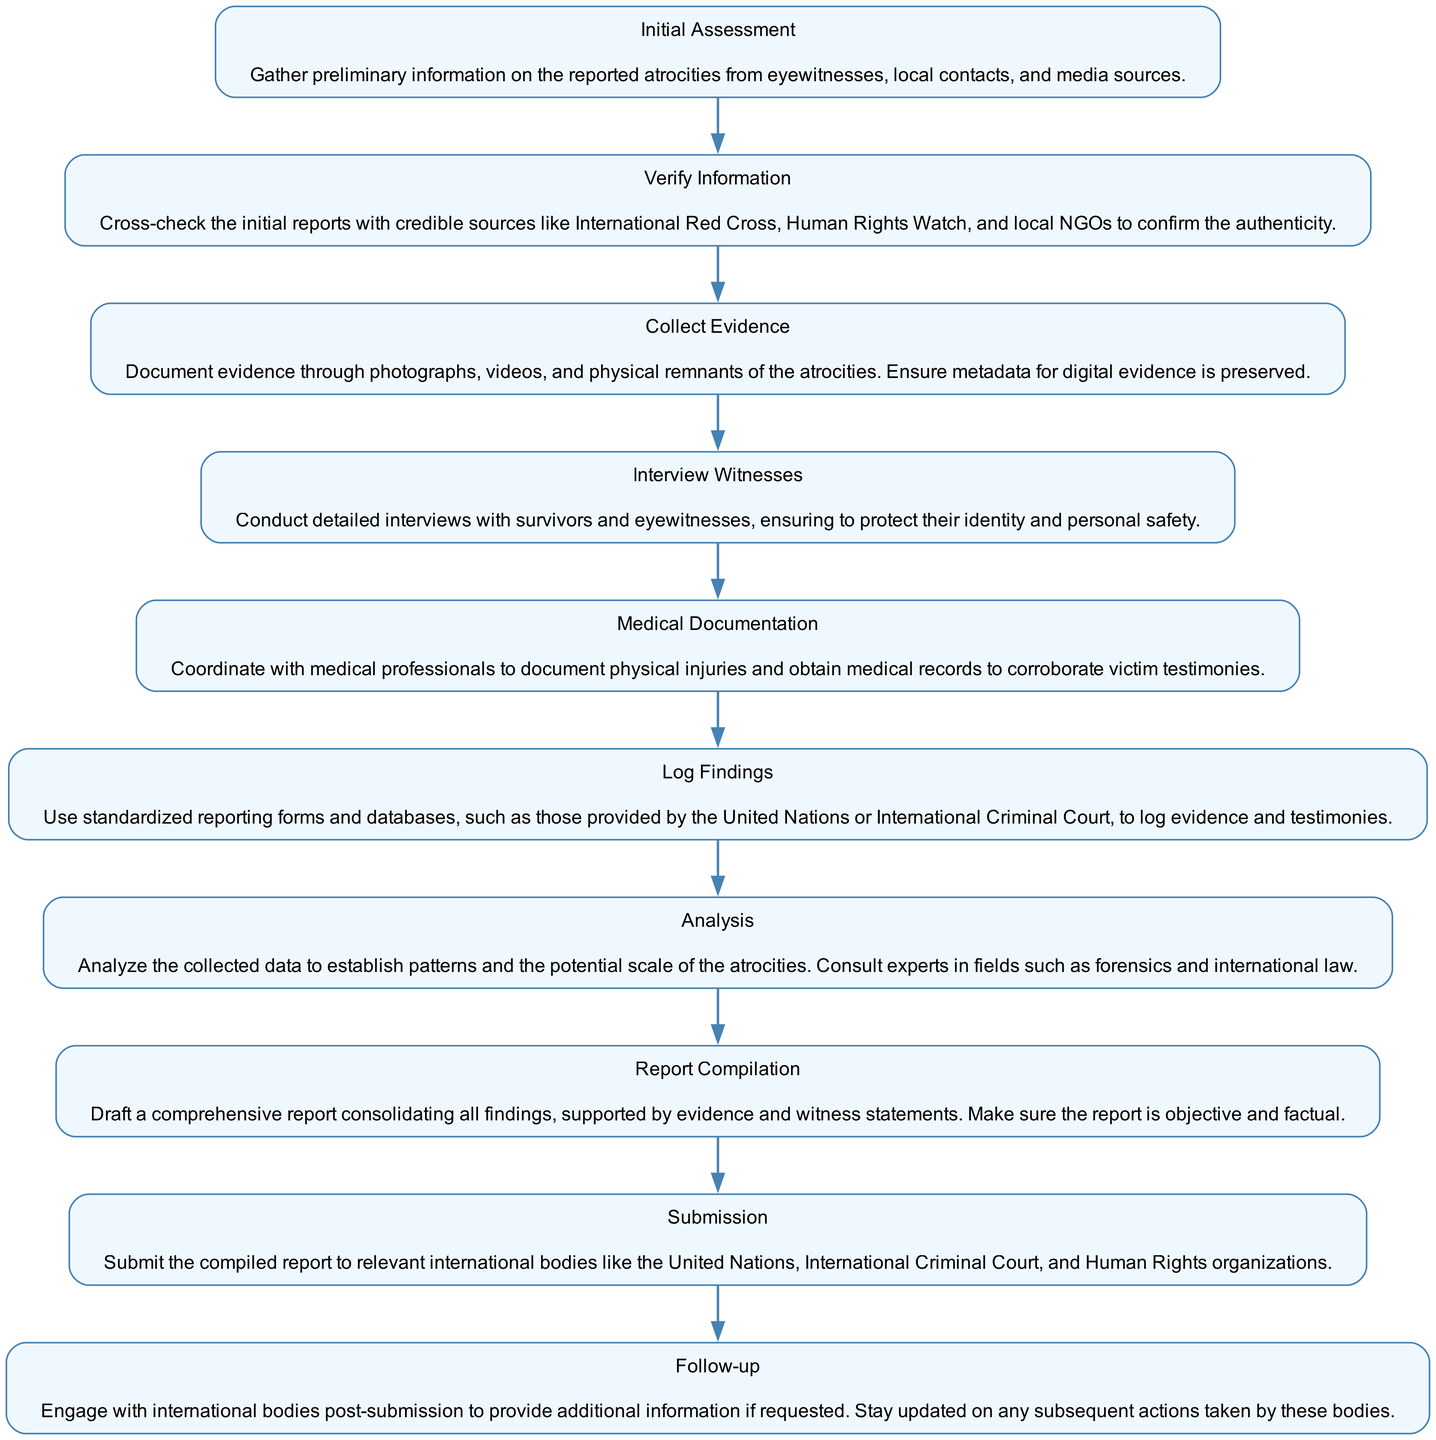What is the first step in documenting war atrocities? The first step listed in the diagram is "Initial Assessment," which involves gathering preliminary information on the reported atrocities from various sources.
Answer: Initial Assessment How many steps are outlined in the diagram? By counting the steps listed in the diagram, we find that there are a total of 10 distinct steps for documenting war atrocities.
Answer: 10 What step comes directly after "Verify Information"? The step that comes after "Verify Information" is "Collect Evidence," indicating a sequential process where verification leads to evidence collection.
Answer: Collect Evidence Which step involves conducting interviews? The step that specifically focuses on conducting interviews with witnesses and survivors is "Interview Witnesses."
Answer: Interview Witnesses What type of documentation is coordinated with medical professionals? The type of documentation that is coordinated with medical professionals is "Medical Documentation," which involves documenting physical injuries and obtaining medical records.
Answer: Medical Documentation Which step follows "Report Compilation" in the process? The step that follows "Report Compilation" is "Submission," indicating that after compiling the report, the next action is to submit it to relevant international bodies.
Answer: Submission What kind of sources should be used to verify information? To verify information, credible sources such as the International Red Cross, Human Rights Watch, and local NGOs should be consulted.
Answer: Credible sources What is the purpose of analyzing the collected data? The purpose of analyzing the collected data is to establish patterns and assess the potential scale of the atrocities, which may involve consulting experts.
Answer: Establish patterns Which step emphasizes the importance of protecting witnesses? The step that emphasizes the importance of protecting witnesses is "Interview Witnesses," which highlights the need for their identity and personal safety during interviews.
Answer: Interview Witnesses What should be used to log evidence and testimonies? Standardized reporting forms and databases provided by organizations such as the United Nations or International Criminal Court should be used to log evidence and testimonies.
Answer: Standardized reporting forms 